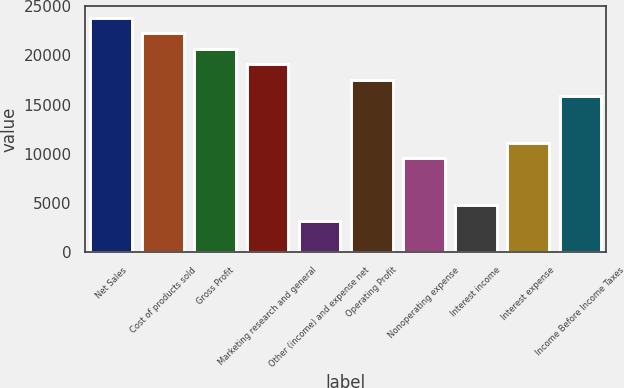<chart> <loc_0><loc_0><loc_500><loc_500><bar_chart><fcel>Net Sales<fcel>Cost of products sold<fcel>Gross Profit<fcel>Marketing research and general<fcel>Other (income) and expense net<fcel>Operating Profit<fcel>Nonoperating expense<fcel>Interest income<fcel>Interest expense<fcel>Income Before Income Taxes<nl><fcel>23852.2<fcel>22262.3<fcel>20672.4<fcel>19082.5<fcel>3183.16<fcel>17492.5<fcel>9542.88<fcel>4773.09<fcel>11132.8<fcel>15902.6<nl></chart> 